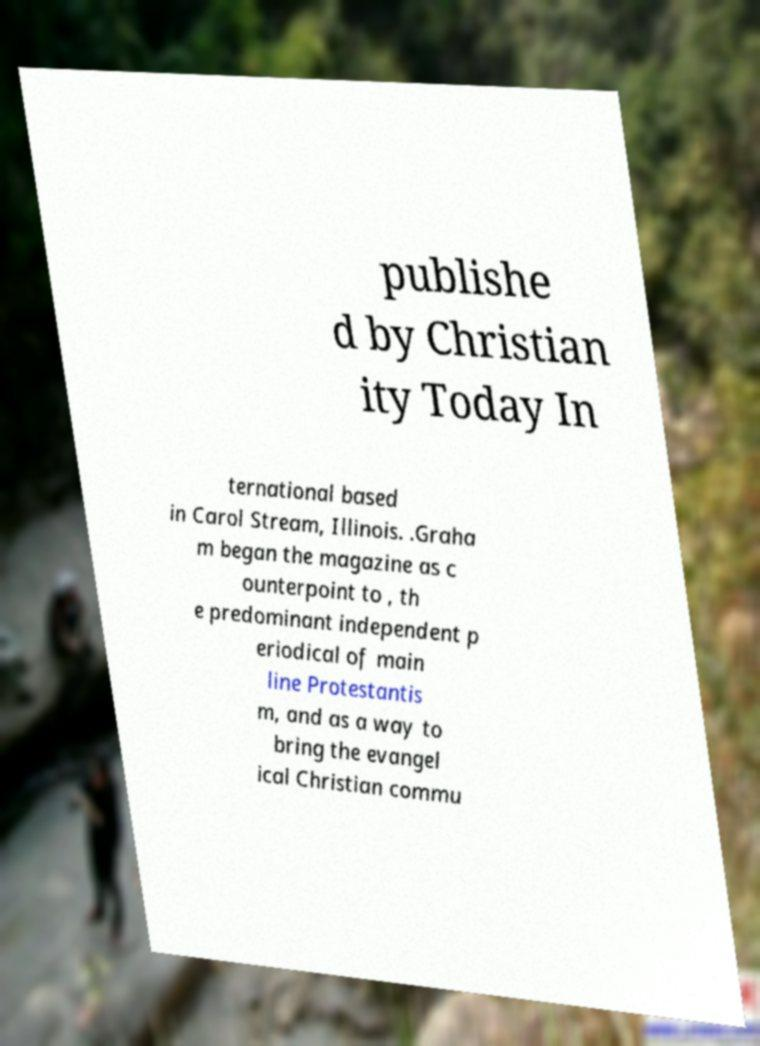What messages or text are displayed in this image? I need them in a readable, typed format. publishe d by Christian ity Today In ternational based in Carol Stream, Illinois. .Graha m began the magazine as c ounterpoint to , th e predominant independent p eriodical of main line Protestantis m, and as a way to bring the evangel ical Christian commu 